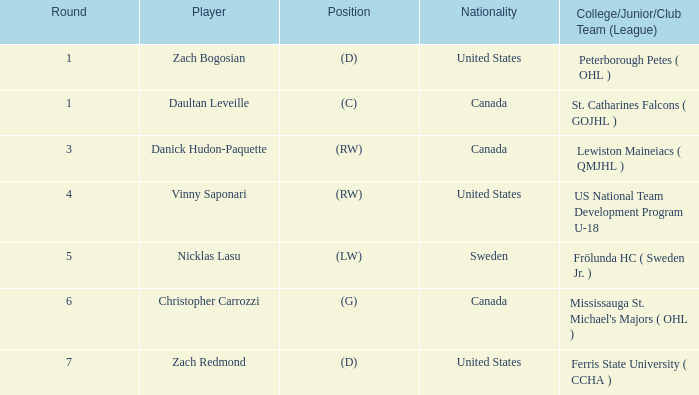What is the participant in round 5? Nicklas Lasu. Could you parse the entire table? {'header': ['Round', 'Player', 'Position', 'Nationality', 'College/Junior/Club Team (League)'], 'rows': [['1', 'Zach Bogosian', '(D)', 'United States', 'Peterborough Petes ( OHL )'], ['1', 'Daultan Leveille', '(C)', 'Canada', 'St. Catharines Falcons ( GOJHL )'], ['3', 'Danick Hudon-Paquette', '(RW)', 'Canada', 'Lewiston Maineiacs ( QMJHL )'], ['4', 'Vinny Saponari', '(RW)', 'United States', 'US National Team Development Program U-18'], ['5', 'Nicklas Lasu', '(LW)', 'Sweden', 'Frölunda HC ( Sweden Jr. )'], ['6', 'Christopher Carrozzi', '(G)', 'Canada', "Mississauga St. Michael's Majors ( OHL )"], ['7', 'Zach Redmond', '(D)', 'United States', 'Ferris State University ( CCHA )']]} 